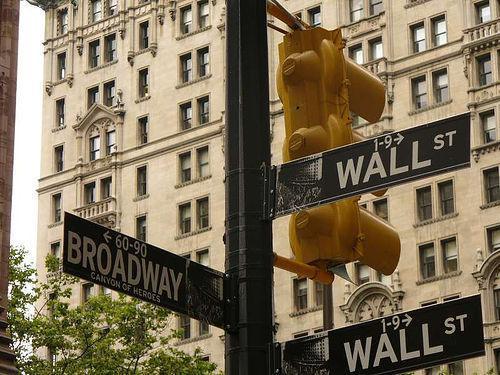How many unique street signs are there?
Give a very brief answer. 2. 